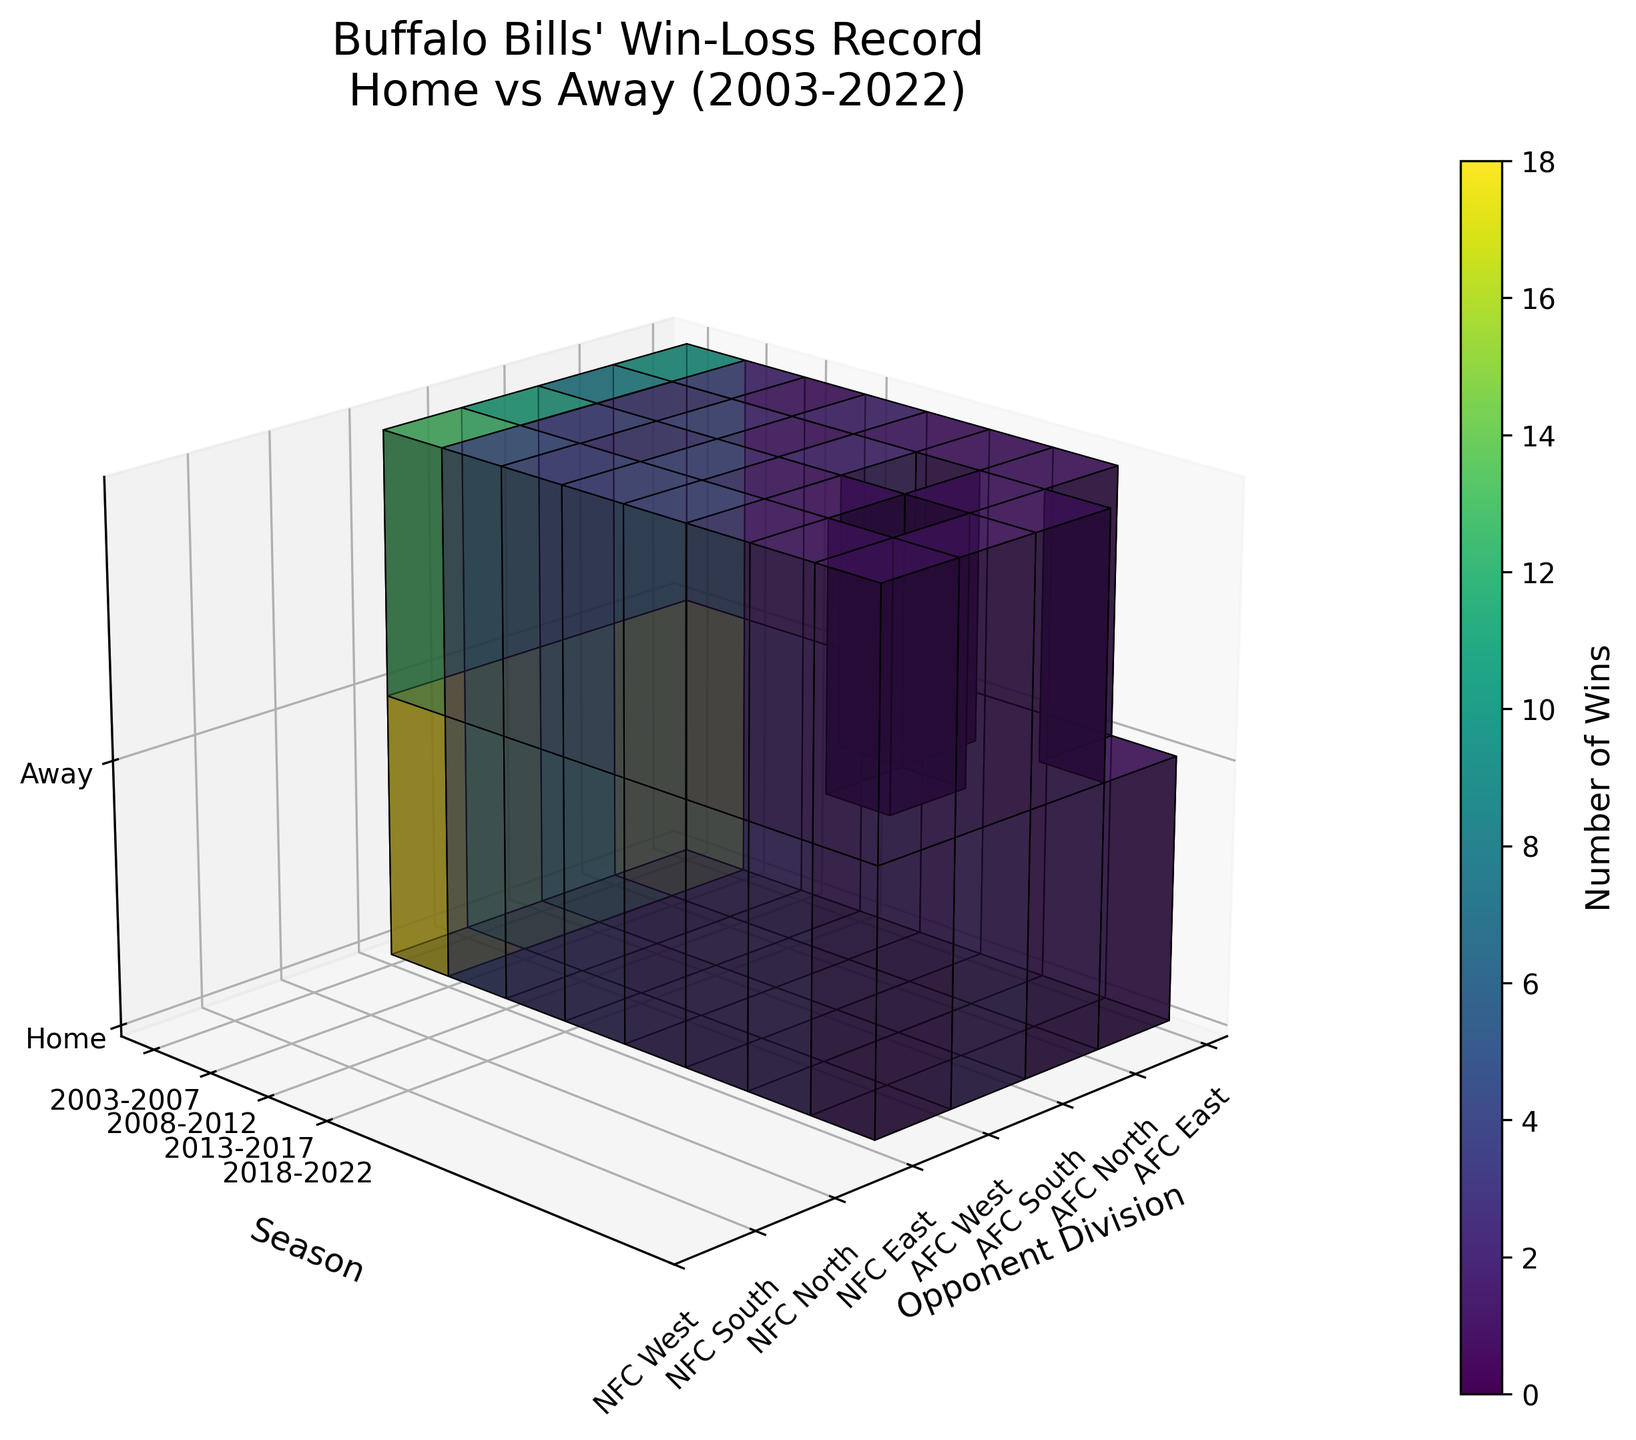What is the title of the figure? The title is displayed at the top center of the figure and it reads "Buffalo Bills' Win-Loss Record\nHome vs Away (2003-2022)"
Answer: Buffalo Bills' Win-Loss Record\nHome vs Away (2003-2022) Which axis represents the seasons? The seasons are labeled along the vertical (Y) axis of the 3D plot.
Answer: Vertical (Y) axis How many divisions are represented on the horizontal axis? The horizontal axis represents 8 divisions, visible as the 8 distinct labels from 'AFC East' to 'NFC West'.
Answer: 8 divisions In which time period did the Buffalo Bills record the most home wins against AFC East opponents? By examining the 'Home' section of the voxel plot, the highest data value (number of wins) is under 'AFC East' for the time period labeled 2018-2022.
Answer: 2018-2022 What was the number of away wins against NFC North opponents in the 2003-2007 period? Looking at the voxel corresponding to 'Away' for NFC North in the 2003-2007 period, the number of wins is 1.
Answer: 1 Which opponent division shows the least number of home wins in the 2013-2017 period? By checking the heights of the home win voxels in the 2013-2017 period, 'NFC South' has the lowest at 1 win.
Answer: NFC South Are there any divisions where the number of away wins was consistently less than the number of home wins across all periods? Yes, for every period, the 'AFC East' division shows fewer away wins compared to home wins by checking the relative heights of the voxels in both 'Home' and 'Away' sections for each period.
Answer: Yes, AFC East What is the average number of home wins across all opponent divisions for the 2008-2012 period? Sum the home win values for 2008-2012: 12 + 2 + 3 + 2 + 3 + 2 + 1 + 1 = 26. Divide by 8 (number of divisions).
Answer: 3.25 Which period experienced the highest total number of away wins? Calculate the total number of away wins for each period by summing the away win values. The period 2018-2022 has the highest sum: 13 + 3 + 2 + 2 + 2 + 1 + 1 + 1 = 25.
Answer: 2018-2022 